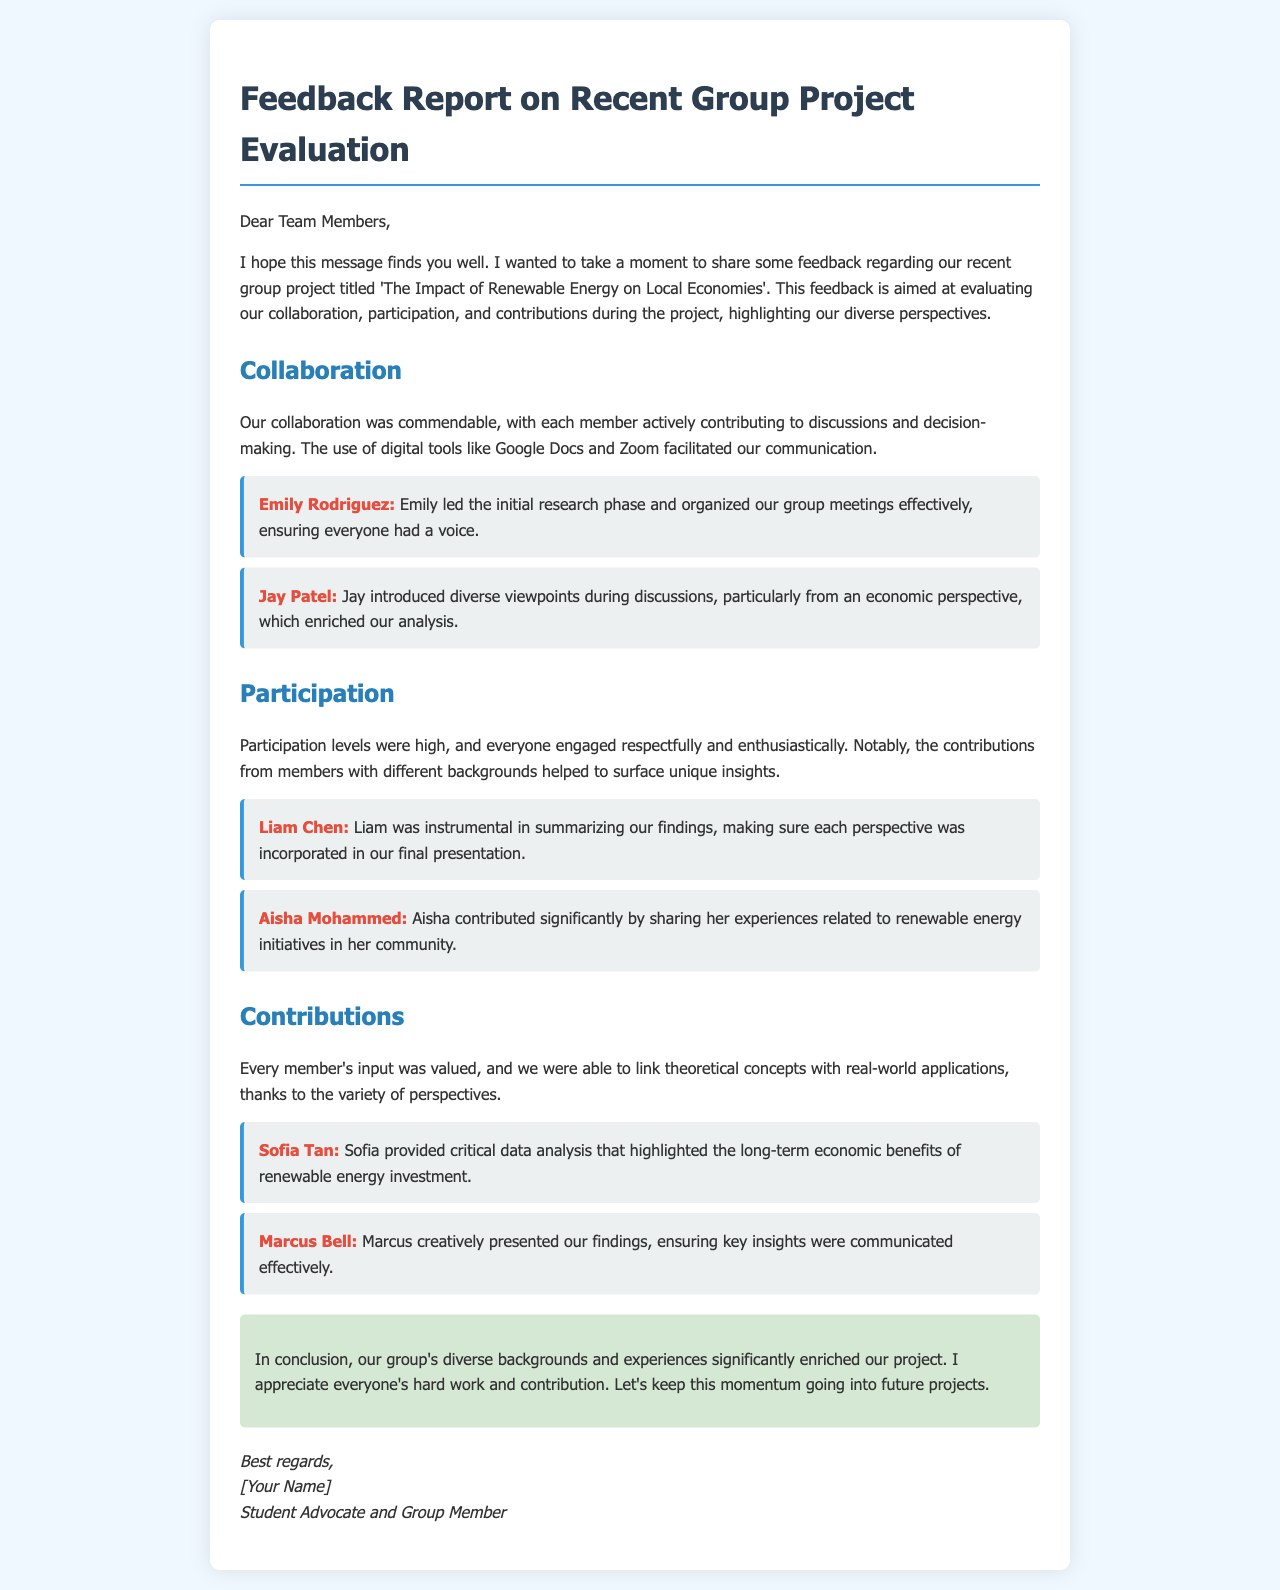What was the title of the group project? The title of the project is explicitly mentioned in the document as 'The Impact of Renewable Energy on Local Economies'.
Answer: The Impact of Renewable Energy on Local Economies Who led the initial research phase? The document specifies that Emily Rodriguez led the initial research phase and organized the group meetings.
Answer: Emily Rodriguez Which digital tools were mentioned in facilitating communication? The text names Google Docs and Zoom as the digital tools used for communication.
Answer: Google Docs and Zoom What contribution did Liam Chen make? Liam Chen is highlighted for summarizing the findings and incorporating different perspectives in the final presentation.
Answer: Summarizing findings How did Aisha Mohammed contribute to the project? The feedback indicates that Aisha shared her experiences related to renewable energy initiatives in her community.
Answer: Shared experiences What was emphasized as a factor that enriched the project? The document credits the group's diverse backgrounds and experiences for significantly enriching their project.
Answer: Diverse backgrounds and experiences What is the conclusion regarding the group's dynamics? The conclusion appreciates the group's hard work and suggests maintaining momentum for future projects.
Answer: Appreciate hard work Who presented the findings creatively? Marcus Bell is recognized in the document for creatively presenting their findings.
Answer: Marcus Bell What is the tone of the feedback report? The tone is supportive and appreciative, aiming to motivate continued collaboration in future projects.
Answer: Supportive and appreciative 